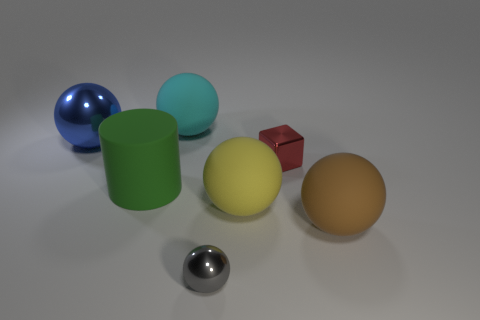How many brown rubber balls are there?
Keep it short and to the point. 1. The ball that is both behind the big yellow ball and on the right side of the green cylinder is what color?
Provide a succinct answer. Cyan. What size is the gray object that is the same shape as the large yellow thing?
Provide a succinct answer. Small. What number of red shiny cubes are the same size as the yellow matte object?
Your answer should be very brief. 0. What material is the gray thing?
Your answer should be very brief. Metal. Are there any large spheres left of the large shiny ball?
Your response must be concise. No. There is a gray sphere that is the same material as the red cube; what is its size?
Ensure brevity in your answer.  Small. Are there fewer big rubber objects in front of the green rubber cylinder than big rubber cylinders that are left of the large blue thing?
Offer a very short reply. No. There is a ball on the right side of the shiny block; how big is it?
Make the answer very short. Large. Are there any other cylinders made of the same material as the green cylinder?
Ensure brevity in your answer.  No. 